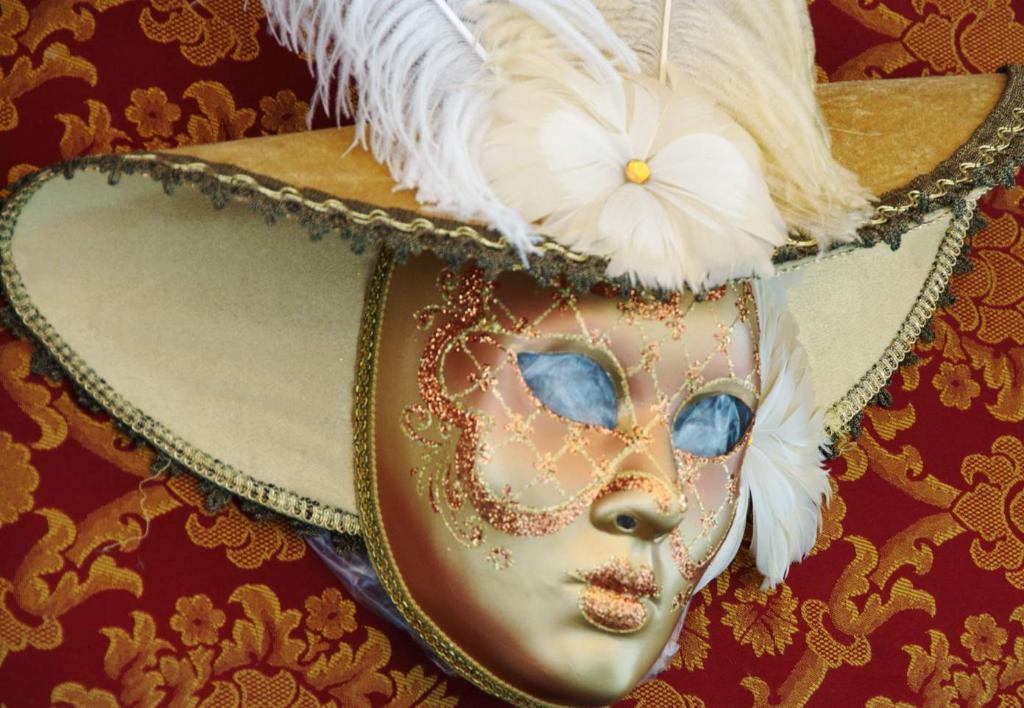Please provide a concise description of this image. In this image there is a mask, behind the mask there is a cloth. 